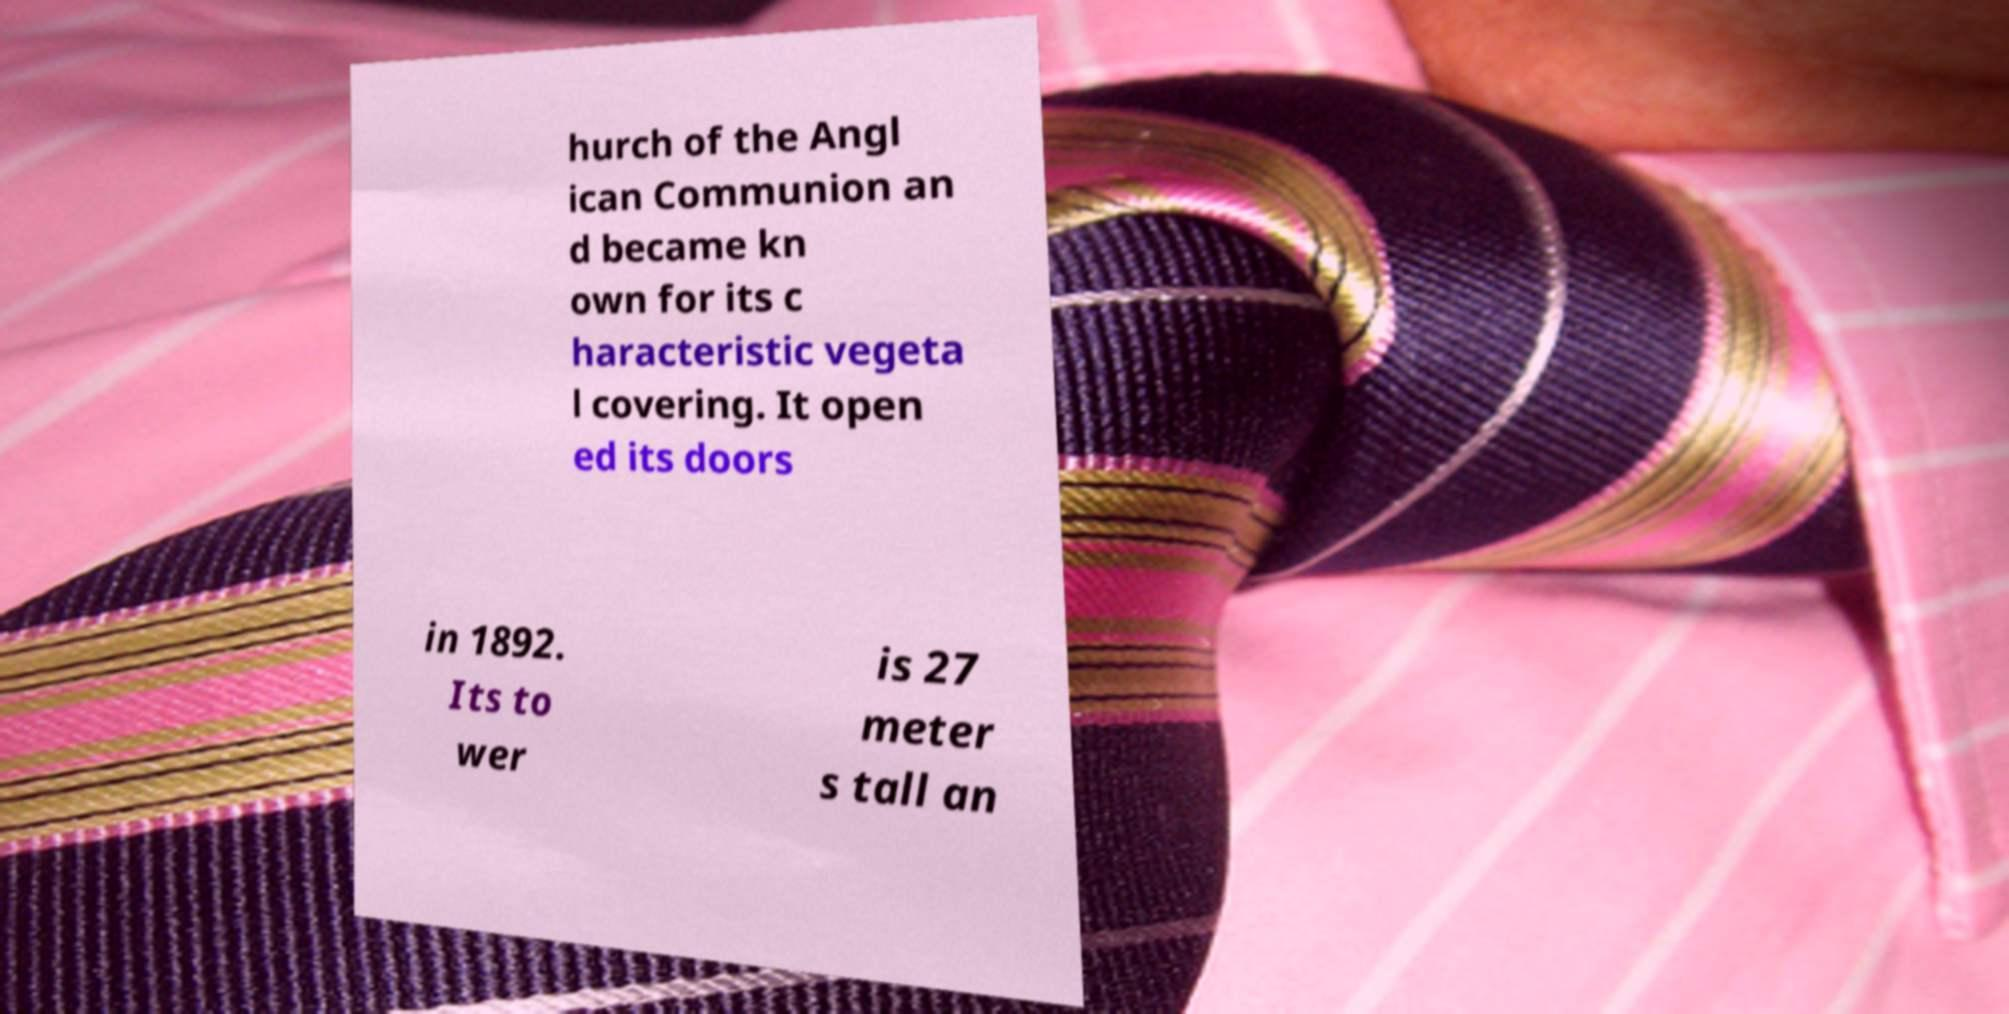Can you read and provide the text displayed in the image?This photo seems to have some interesting text. Can you extract and type it out for me? hurch of the Angl ican Communion an d became kn own for its c haracteristic vegeta l covering. It open ed its doors in 1892. Its to wer is 27 meter s tall an 